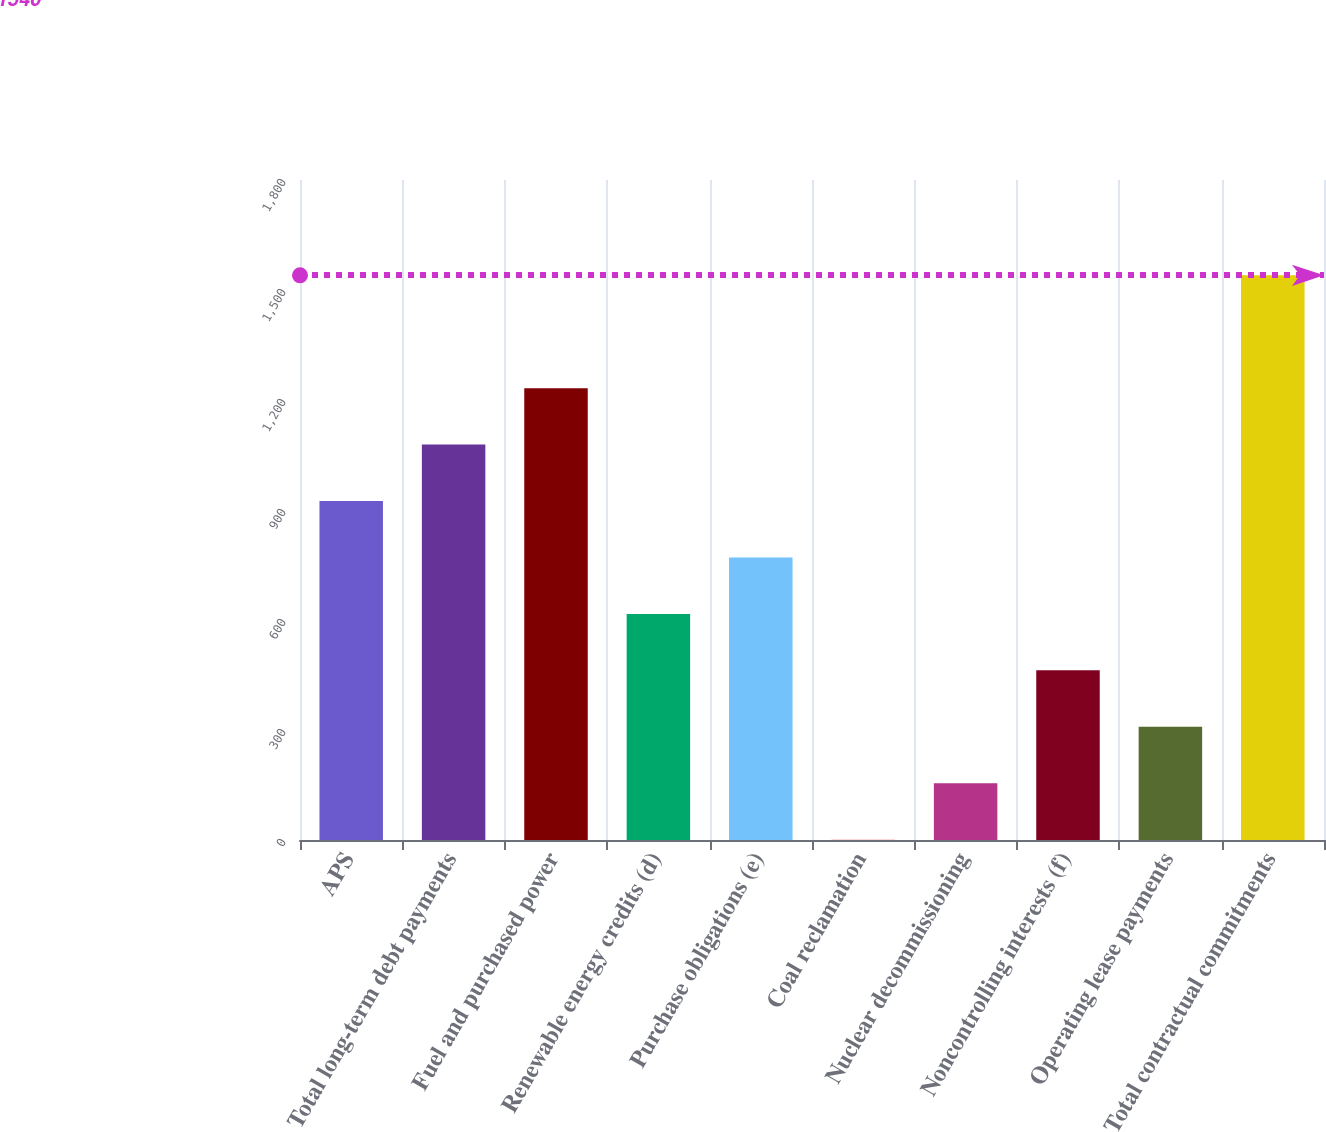<chart> <loc_0><loc_0><loc_500><loc_500><bar_chart><fcel>APS<fcel>Total long-term debt payments<fcel>Fuel and purchased power<fcel>Renewable energy credits (d)<fcel>Purchase obligations (e)<fcel>Coal reclamation<fcel>Nuclear decommissioning<fcel>Noncontrolling interests (f)<fcel>Operating lease payments<fcel>Total contractual commitments<nl><fcel>924.4<fcel>1078.3<fcel>1232.2<fcel>616.6<fcel>770.5<fcel>1<fcel>154.9<fcel>462.7<fcel>308.8<fcel>1540<nl></chart> 